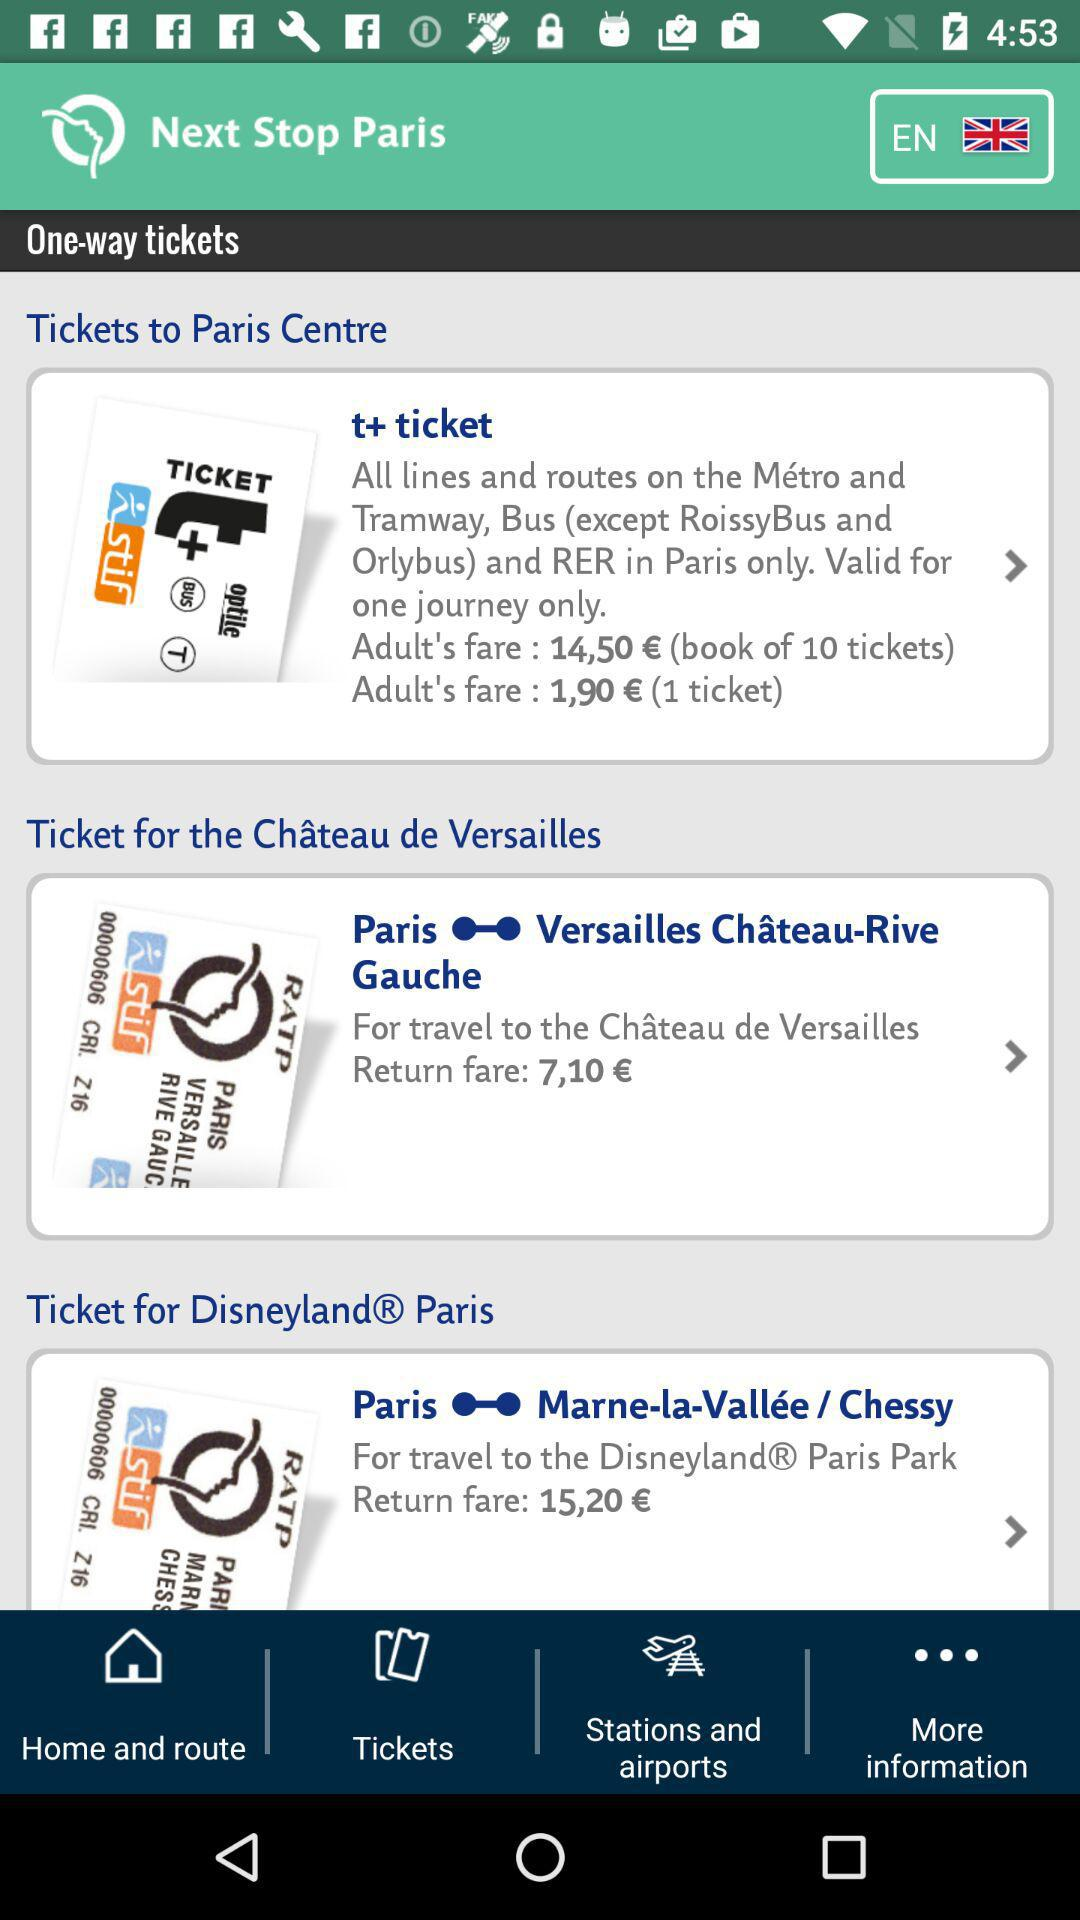How much is a ticket for a return from Versailles to Paris? A return ticket from Versailles to Paris costs 7,10€. 